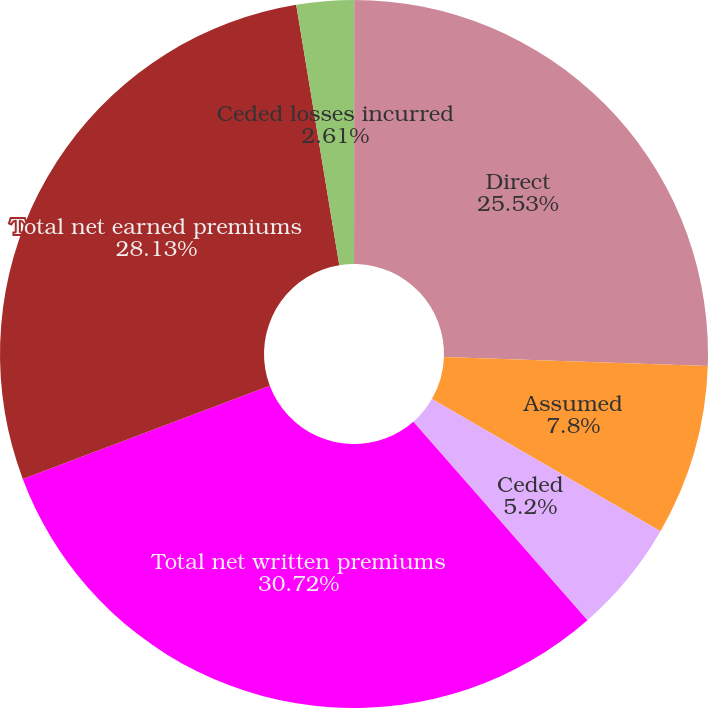<chart> <loc_0><loc_0><loc_500><loc_500><pie_chart><fcel>(In thousands)<fcel>Direct<fcel>Assumed<fcel>Ceded<fcel>Total net written premiums<fcel>Total net earned premiums<fcel>Ceded losses incurred<nl><fcel>0.01%<fcel>25.53%<fcel>7.8%<fcel>5.2%<fcel>30.72%<fcel>28.13%<fcel>2.61%<nl></chart> 